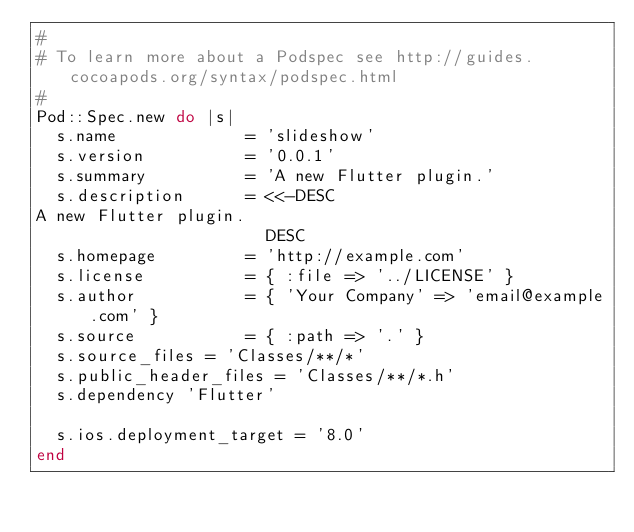<code> <loc_0><loc_0><loc_500><loc_500><_Ruby_>#
# To learn more about a Podspec see http://guides.cocoapods.org/syntax/podspec.html
#
Pod::Spec.new do |s|
  s.name             = 'slideshow'
  s.version          = '0.0.1'
  s.summary          = 'A new Flutter plugin.'
  s.description      = <<-DESC
A new Flutter plugin.
                       DESC
  s.homepage         = 'http://example.com'
  s.license          = { :file => '../LICENSE' }
  s.author           = { 'Your Company' => 'email@example.com' }
  s.source           = { :path => '.' }
  s.source_files = 'Classes/**/*'
  s.public_header_files = 'Classes/**/*.h'
  s.dependency 'Flutter'

  s.ios.deployment_target = '8.0'
end

</code> 